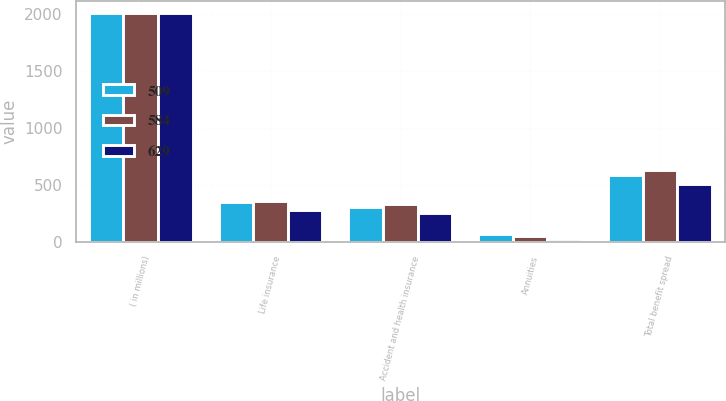Convert chart. <chart><loc_0><loc_0><loc_500><loc_500><stacked_bar_chart><ecel><fcel>( in millions)<fcel>Life insurance<fcel>Accident and health insurance<fcel>Annuities<fcel>Total benefit spread<nl><fcel>509<fcel>2012<fcel>347<fcel>303<fcel>66<fcel>584<nl><fcel>584<fcel>2011<fcel>355<fcel>329<fcel>55<fcel>629<nl><fcel>629<fcel>2010<fcel>282<fcel>252<fcel>25<fcel>509<nl></chart> 